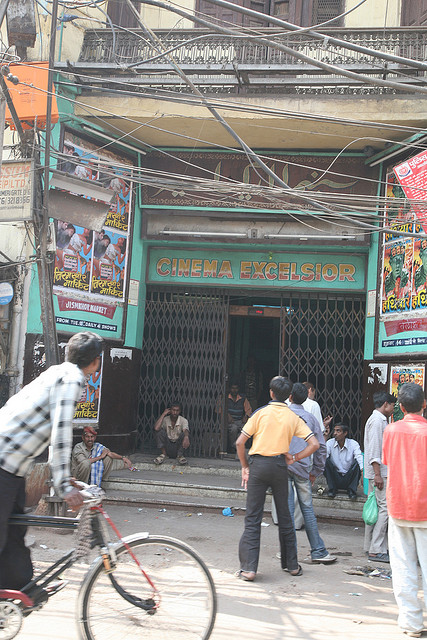How many people are visible near the cinema entrance? Near the cinema entrance, there are around six people visible. They appear to be engaged in various activities such as conversing with each other, sitting by the entrance, or passing by. This suggests a dynamic social interaction is taking place, typical of a neighborhood hub. 